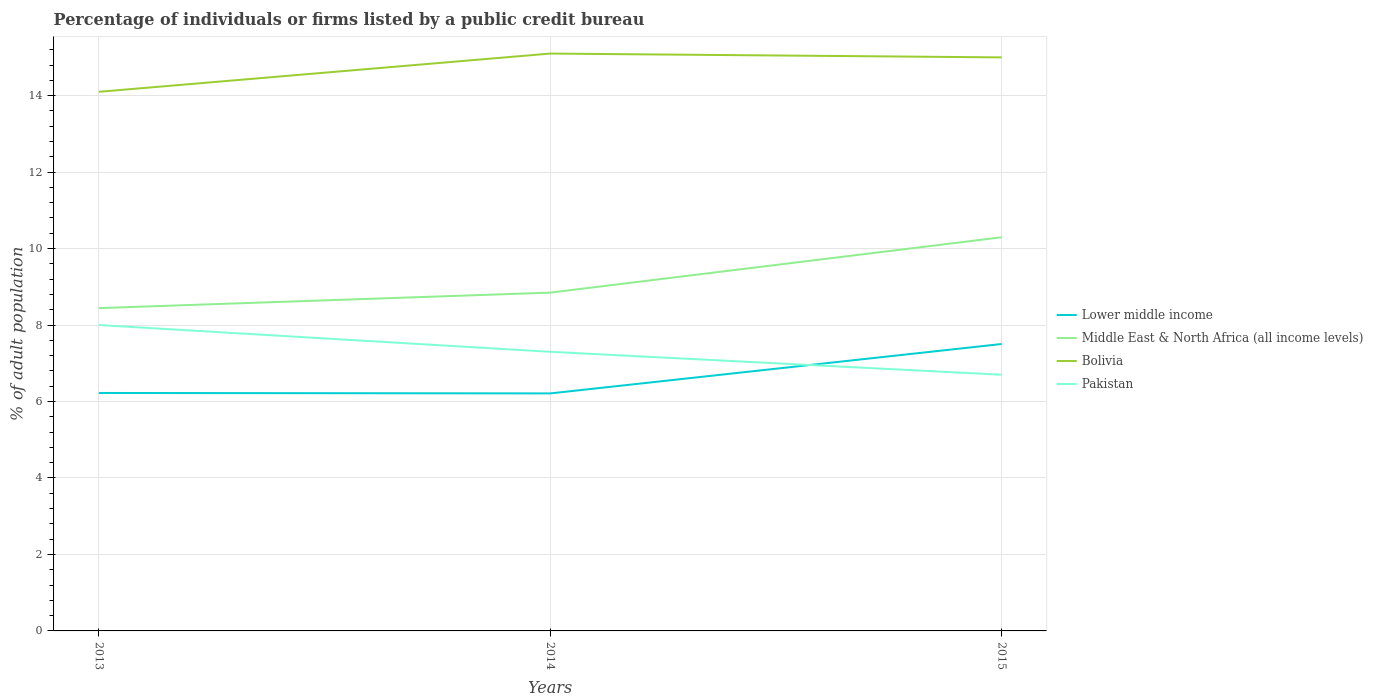How many different coloured lines are there?
Provide a short and direct response. 4. Does the line corresponding to Lower middle income intersect with the line corresponding to Pakistan?
Keep it short and to the point. Yes. Is the number of lines equal to the number of legend labels?
Give a very brief answer. Yes. Across all years, what is the maximum percentage of population listed by a public credit bureau in Lower middle income?
Your response must be concise. 6.21. In which year was the percentage of population listed by a public credit bureau in Pakistan maximum?
Offer a very short reply. 2015. What is the total percentage of population listed by a public credit bureau in Middle East & North Africa (all income levels) in the graph?
Offer a terse response. -0.4. What is the difference between the highest and the lowest percentage of population listed by a public credit bureau in Pakistan?
Provide a succinct answer. 1. Is the percentage of population listed by a public credit bureau in Lower middle income strictly greater than the percentage of population listed by a public credit bureau in Middle East & North Africa (all income levels) over the years?
Ensure brevity in your answer.  Yes. How many lines are there?
Make the answer very short. 4. How many years are there in the graph?
Offer a terse response. 3. Where does the legend appear in the graph?
Offer a very short reply. Center right. What is the title of the graph?
Offer a very short reply. Percentage of individuals or firms listed by a public credit bureau. What is the label or title of the X-axis?
Provide a short and direct response. Years. What is the label or title of the Y-axis?
Offer a very short reply. % of adult population. What is the % of adult population in Lower middle income in 2013?
Ensure brevity in your answer.  6.22. What is the % of adult population in Middle East & North Africa (all income levels) in 2013?
Provide a succinct answer. 8.44. What is the % of adult population of Bolivia in 2013?
Your response must be concise. 14.1. What is the % of adult population in Lower middle income in 2014?
Make the answer very short. 6.21. What is the % of adult population of Middle East & North Africa (all income levels) in 2014?
Keep it short and to the point. 8.85. What is the % of adult population in Bolivia in 2014?
Your answer should be compact. 15.1. What is the % of adult population of Pakistan in 2014?
Keep it short and to the point. 7.3. What is the % of adult population in Lower middle income in 2015?
Provide a short and direct response. 7.5. What is the % of adult population in Middle East & North Africa (all income levels) in 2015?
Offer a terse response. 10.3. What is the % of adult population in Pakistan in 2015?
Offer a terse response. 6.7. Across all years, what is the maximum % of adult population in Lower middle income?
Offer a very short reply. 7.5. Across all years, what is the maximum % of adult population in Middle East & North Africa (all income levels)?
Make the answer very short. 10.3. Across all years, what is the minimum % of adult population of Lower middle income?
Give a very brief answer. 6.21. Across all years, what is the minimum % of adult population of Middle East & North Africa (all income levels)?
Give a very brief answer. 8.44. Across all years, what is the minimum % of adult population in Pakistan?
Make the answer very short. 6.7. What is the total % of adult population in Lower middle income in the graph?
Offer a terse response. 19.94. What is the total % of adult population in Middle East & North Africa (all income levels) in the graph?
Ensure brevity in your answer.  27.59. What is the total % of adult population in Bolivia in the graph?
Ensure brevity in your answer.  44.2. What is the difference between the % of adult population of Lower middle income in 2013 and that in 2014?
Ensure brevity in your answer.  0.01. What is the difference between the % of adult population in Middle East & North Africa (all income levels) in 2013 and that in 2014?
Make the answer very short. -0.4. What is the difference between the % of adult population of Lower middle income in 2013 and that in 2015?
Offer a terse response. -1.28. What is the difference between the % of adult population in Middle East & North Africa (all income levels) in 2013 and that in 2015?
Your response must be concise. -1.85. What is the difference between the % of adult population of Bolivia in 2013 and that in 2015?
Offer a terse response. -0.9. What is the difference between the % of adult population in Pakistan in 2013 and that in 2015?
Ensure brevity in your answer.  1.3. What is the difference between the % of adult population of Lower middle income in 2014 and that in 2015?
Give a very brief answer. -1.29. What is the difference between the % of adult population in Middle East & North Africa (all income levels) in 2014 and that in 2015?
Offer a very short reply. -1.45. What is the difference between the % of adult population of Bolivia in 2014 and that in 2015?
Offer a very short reply. 0.1. What is the difference between the % of adult population of Pakistan in 2014 and that in 2015?
Offer a terse response. 0.6. What is the difference between the % of adult population in Lower middle income in 2013 and the % of adult population in Middle East & North Africa (all income levels) in 2014?
Provide a short and direct response. -2.62. What is the difference between the % of adult population in Lower middle income in 2013 and the % of adult population in Bolivia in 2014?
Provide a short and direct response. -8.88. What is the difference between the % of adult population in Lower middle income in 2013 and the % of adult population in Pakistan in 2014?
Offer a terse response. -1.08. What is the difference between the % of adult population in Middle East & North Africa (all income levels) in 2013 and the % of adult population in Bolivia in 2014?
Provide a short and direct response. -6.66. What is the difference between the % of adult population in Middle East & North Africa (all income levels) in 2013 and the % of adult population in Pakistan in 2014?
Your answer should be very brief. 1.14. What is the difference between the % of adult population of Lower middle income in 2013 and the % of adult population of Middle East & North Africa (all income levels) in 2015?
Keep it short and to the point. -4.07. What is the difference between the % of adult population of Lower middle income in 2013 and the % of adult population of Bolivia in 2015?
Give a very brief answer. -8.78. What is the difference between the % of adult population in Lower middle income in 2013 and the % of adult population in Pakistan in 2015?
Make the answer very short. -0.48. What is the difference between the % of adult population of Middle East & North Africa (all income levels) in 2013 and the % of adult population of Bolivia in 2015?
Your answer should be compact. -6.56. What is the difference between the % of adult population in Middle East & North Africa (all income levels) in 2013 and the % of adult population in Pakistan in 2015?
Keep it short and to the point. 1.74. What is the difference between the % of adult population in Lower middle income in 2014 and the % of adult population in Middle East & North Africa (all income levels) in 2015?
Provide a short and direct response. -4.08. What is the difference between the % of adult population of Lower middle income in 2014 and the % of adult population of Bolivia in 2015?
Provide a short and direct response. -8.79. What is the difference between the % of adult population in Lower middle income in 2014 and the % of adult population in Pakistan in 2015?
Ensure brevity in your answer.  -0.49. What is the difference between the % of adult population of Middle East & North Africa (all income levels) in 2014 and the % of adult population of Bolivia in 2015?
Your answer should be very brief. -6.15. What is the difference between the % of adult population of Middle East & North Africa (all income levels) in 2014 and the % of adult population of Pakistan in 2015?
Your response must be concise. 2.15. What is the difference between the % of adult population in Bolivia in 2014 and the % of adult population in Pakistan in 2015?
Your response must be concise. 8.4. What is the average % of adult population in Lower middle income per year?
Offer a very short reply. 6.65. What is the average % of adult population in Middle East & North Africa (all income levels) per year?
Ensure brevity in your answer.  9.2. What is the average % of adult population in Bolivia per year?
Offer a very short reply. 14.73. What is the average % of adult population in Pakistan per year?
Make the answer very short. 7.33. In the year 2013, what is the difference between the % of adult population of Lower middle income and % of adult population of Middle East & North Africa (all income levels)?
Give a very brief answer. -2.22. In the year 2013, what is the difference between the % of adult population of Lower middle income and % of adult population of Bolivia?
Offer a very short reply. -7.88. In the year 2013, what is the difference between the % of adult population of Lower middle income and % of adult population of Pakistan?
Offer a very short reply. -1.78. In the year 2013, what is the difference between the % of adult population in Middle East & North Africa (all income levels) and % of adult population in Bolivia?
Provide a short and direct response. -5.66. In the year 2013, what is the difference between the % of adult population of Middle East & North Africa (all income levels) and % of adult population of Pakistan?
Your answer should be very brief. 0.44. In the year 2013, what is the difference between the % of adult population in Bolivia and % of adult population in Pakistan?
Ensure brevity in your answer.  6.1. In the year 2014, what is the difference between the % of adult population of Lower middle income and % of adult population of Middle East & North Africa (all income levels)?
Make the answer very short. -2.64. In the year 2014, what is the difference between the % of adult population of Lower middle income and % of adult population of Bolivia?
Offer a terse response. -8.89. In the year 2014, what is the difference between the % of adult population in Lower middle income and % of adult population in Pakistan?
Your response must be concise. -1.09. In the year 2014, what is the difference between the % of adult population of Middle East & North Africa (all income levels) and % of adult population of Bolivia?
Offer a terse response. -6.25. In the year 2014, what is the difference between the % of adult population of Middle East & North Africa (all income levels) and % of adult population of Pakistan?
Provide a succinct answer. 1.55. In the year 2014, what is the difference between the % of adult population in Bolivia and % of adult population in Pakistan?
Offer a terse response. 7.8. In the year 2015, what is the difference between the % of adult population of Lower middle income and % of adult population of Middle East & North Africa (all income levels)?
Keep it short and to the point. -2.79. In the year 2015, what is the difference between the % of adult population of Lower middle income and % of adult population of Bolivia?
Provide a succinct answer. -7.5. In the year 2015, what is the difference between the % of adult population in Lower middle income and % of adult population in Pakistan?
Ensure brevity in your answer.  0.8. In the year 2015, what is the difference between the % of adult population in Middle East & North Africa (all income levels) and % of adult population in Bolivia?
Offer a very short reply. -4.7. In the year 2015, what is the difference between the % of adult population of Middle East & North Africa (all income levels) and % of adult population of Pakistan?
Your response must be concise. 3.6. In the year 2015, what is the difference between the % of adult population in Bolivia and % of adult population in Pakistan?
Provide a succinct answer. 8.3. What is the ratio of the % of adult population of Lower middle income in 2013 to that in 2014?
Give a very brief answer. 1. What is the ratio of the % of adult population in Middle East & North Africa (all income levels) in 2013 to that in 2014?
Offer a terse response. 0.95. What is the ratio of the % of adult population of Bolivia in 2013 to that in 2014?
Offer a terse response. 0.93. What is the ratio of the % of adult population of Pakistan in 2013 to that in 2014?
Your answer should be compact. 1.1. What is the ratio of the % of adult population in Lower middle income in 2013 to that in 2015?
Make the answer very short. 0.83. What is the ratio of the % of adult population of Middle East & North Africa (all income levels) in 2013 to that in 2015?
Make the answer very short. 0.82. What is the ratio of the % of adult population of Pakistan in 2013 to that in 2015?
Offer a terse response. 1.19. What is the ratio of the % of adult population in Lower middle income in 2014 to that in 2015?
Your answer should be compact. 0.83. What is the ratio of the % of adult population in Middle East & North Africa (all income levels) in 2014 to that in 2015?
Your answer should be compact. 0.86. What is the ratio of the % of adult population of Bolivia in 2014 to that in 2015?
Offer a very short reply. 1.01. What is the ratio of the % of adult population in Pakistan in 2014 to that in 2015?
Your answer should be compact. 1.09. What is the difference between the highest and the second highest % of adult population of Lower middle income?
Offer a terse response. 1.28. What is the difference between the highest and the second highest % of adult population in Middle East & North Africa (all income levels)?
Offer a very short reply. 1.45. What is the difference between the highest and the second highest % of adult population in Pakistan?
Offer a terse response. 0.7. What is the difference between the highest and the lowest % of adult population in Lower middle income?
Make the answer very short. 1.29. What is the difference between the highest and the lowest % of adult population of Middle East & North Africa (all income levels)?
Offer a terse response. 1.85. What is the difference between the highest and the lowest % of adult population of Pakistan?
Your answer should be very brief. 1.3. 